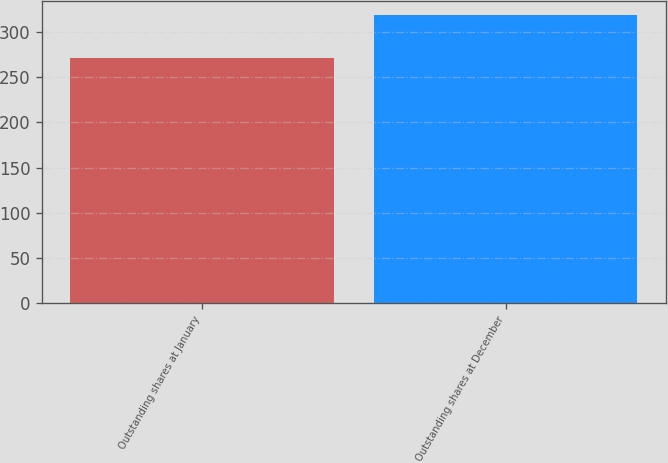Convert chart. <chart><loc_0><loc_0><loc_500><loc_500><bar_chart><fcel>Outstanding shares at January<fcel>Outstanding shares at December<nl><fcel>271.08<fcel>319<nl></chart> 